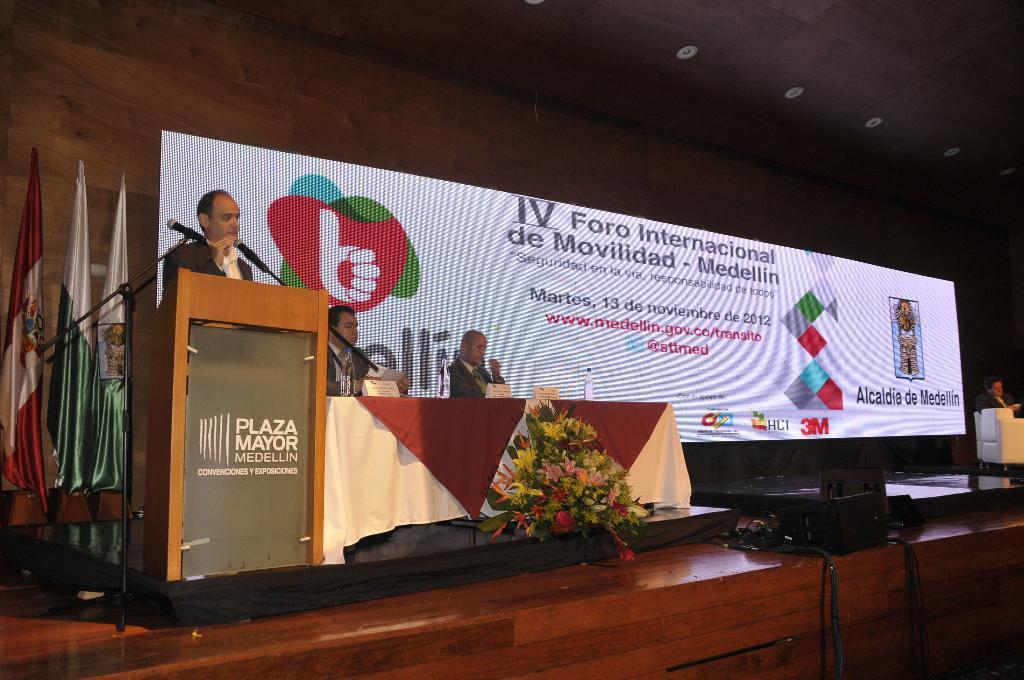Can you describe this image briefly? There is a person standing. In front of him there is a podium with poster. Also there are mics with mic stands. Near to him there are two persons sitting. In front of them there is a table. On that there is a cloth, bottles and name boards. In front of that there is a flower bouquet. In the back there are flags and a screen with something written on that. On the right side there is a person sitting on a chair. There is a speaker on the stage. 